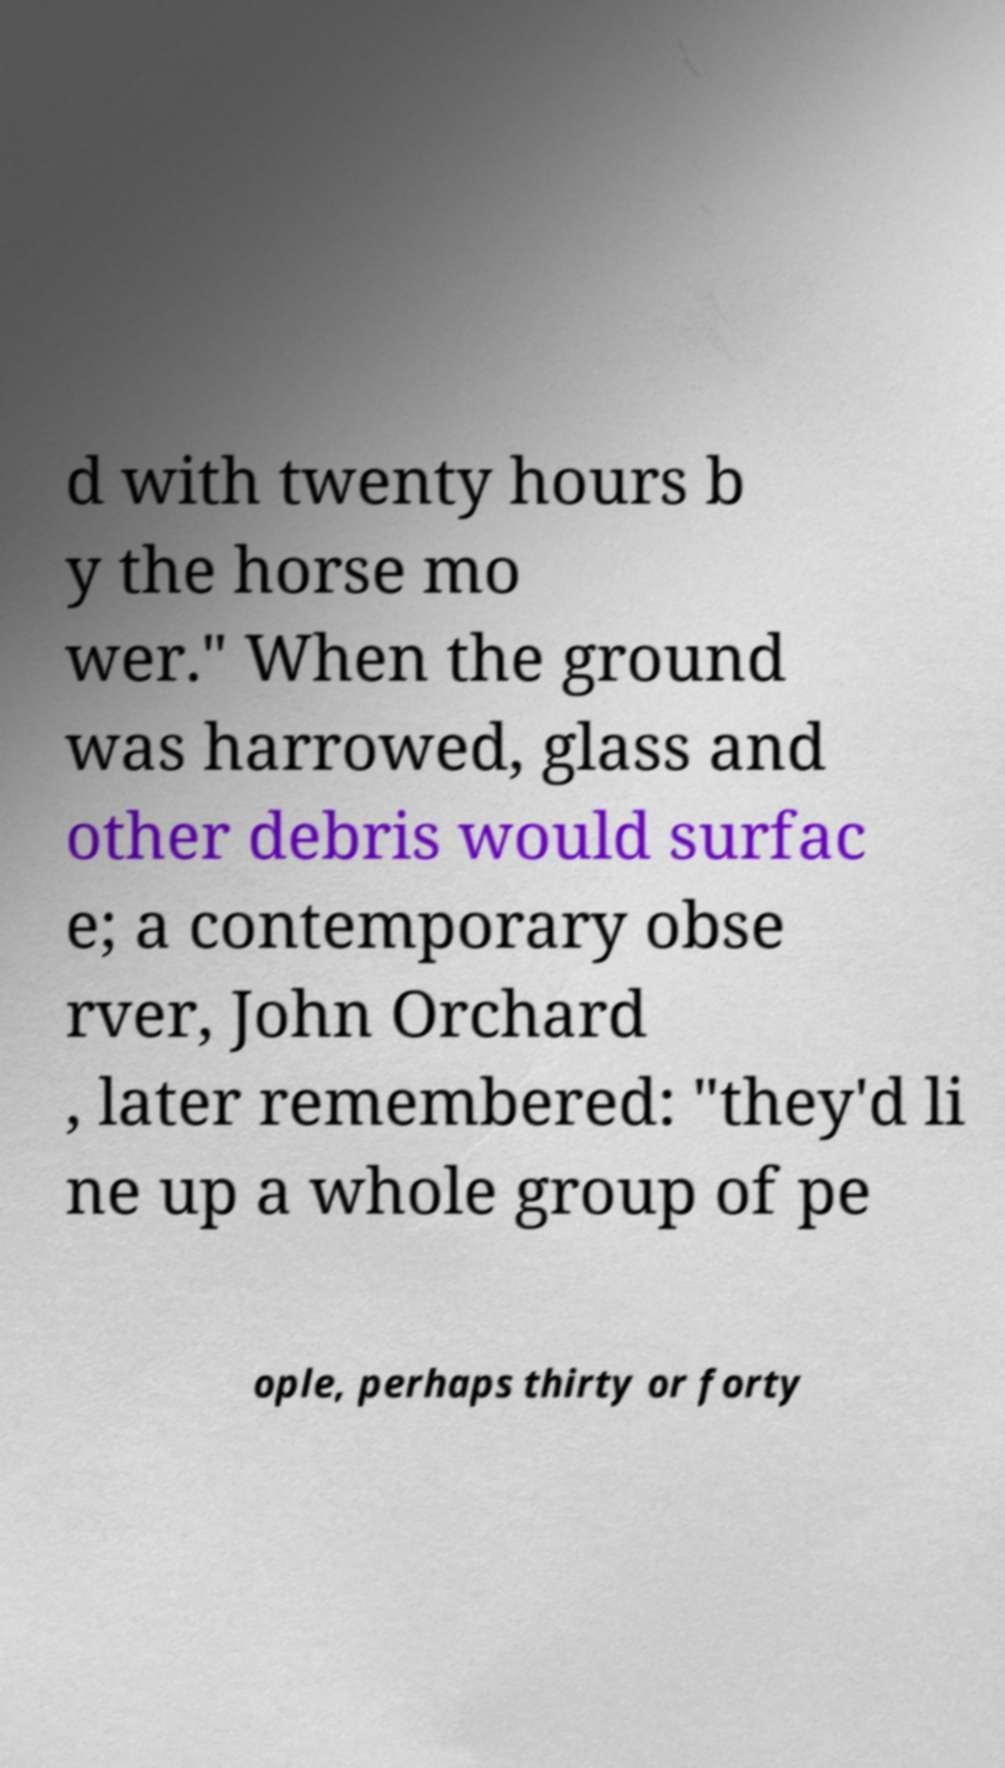I need the written content from this picture converted into text. Can you do that? d with twenty hours b y the horse mo wer." When the ground was harrowed, glass and other debris would surfac e; a contemporary obse rver, John Orchard , later remembered: "they'd li ne up a whole group of pe ople, perhaps thirty or forty 